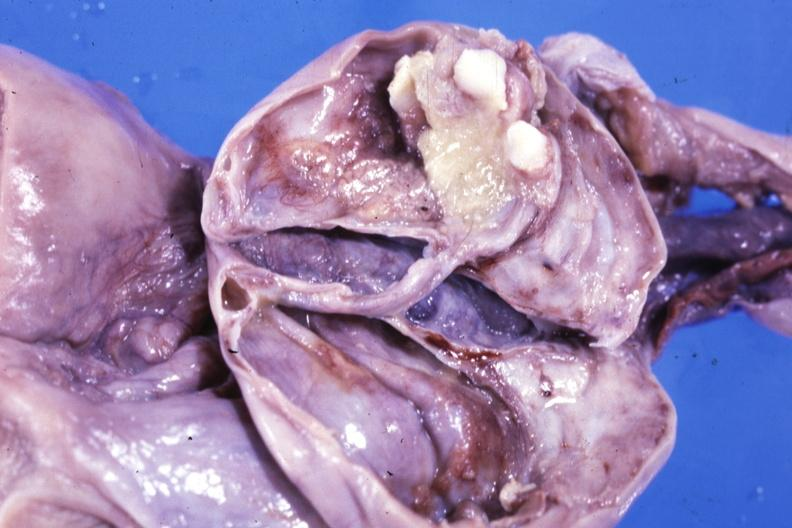how many teeth is fixed tissue opened ovarian cyst with two or?
Answer the question using a single word or phrase. Three 